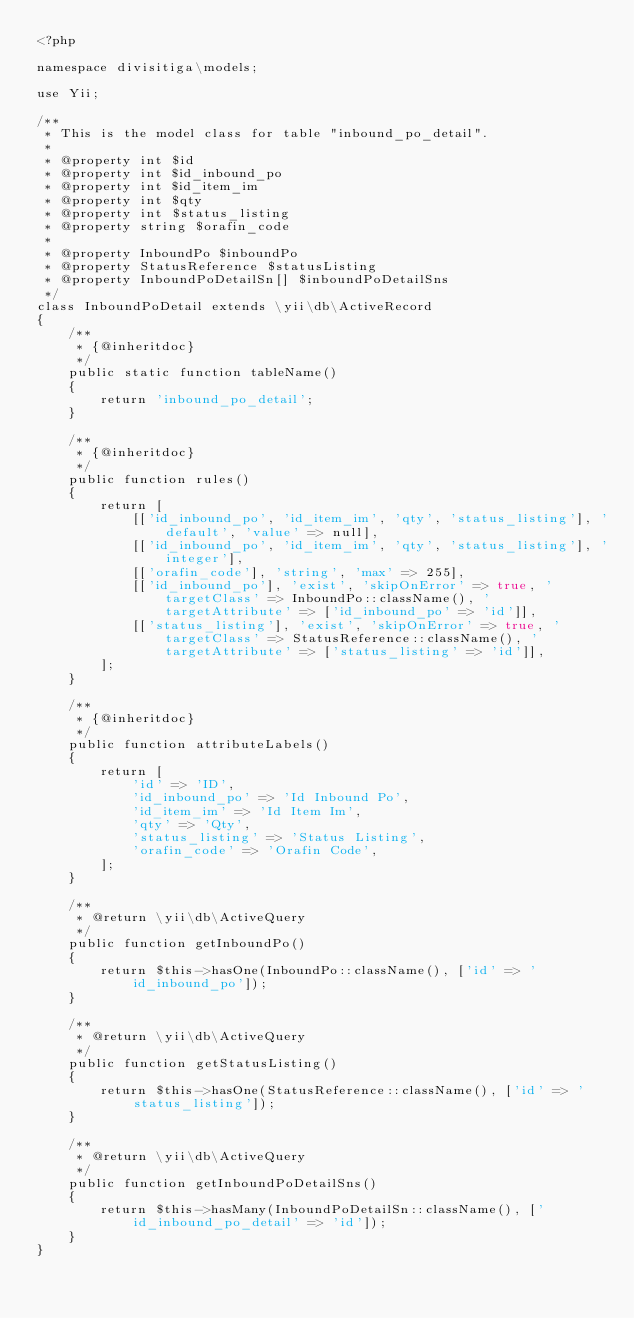<code> <loc_0><loc_0><loc_500><loc_500><_PHP_><?php

namespace divisitiga\models;

use Yii;

/**
 * This is the model class for table "inbound_po_detail".
 *
 * @property int $id
 * @property int $id_inbound_po
 * @property int $id_item_im
 * @property int $qty
 * @property int $status_listing
 * @property string $orafin_code
 *
 * @property InboundPo $inboundPo
 * @property StatusReference $statusListing
 * @property InboundPoDetailSn[] $inboundPoDetailSns
 */
class InboundPoDetail extends \yii\db\ActiveRecord
{
    /**
     * {@inheritdoc}
     */
    public static function tableName()
    {
        return 'inbound_po_detail';
    }

    /**
     * {@inheritdoc}
     */
    public function rules()
    {
        return [
            [['id_inbound_po', 'id_item_im', 'qty', 'status_listing'], 'default', 'value' => null],
            [['id_inbound_po', 'id_item_im', 'qty', 'status_listing'], 'integer'],
            [['orafin_code'], 'string', 'max' => 255],
            [['id_inbound_po'], 'exist', 'skipOnError' => true, 'targetClass' => InboundPo::className(), 'targetAttribute' => ['id_inbound_po' => 'id']],
            [['status_listing'], 'exist', 'skipOnError' => true, 'targetClass' => StatusReference::className(), 'targetAttribute' => ['status_listing' => 'id']],
        ];
    }

    /**
     * {@inheritdoc}
     */
    public function attributeLabels()
    {
        return [
            'id' => 'ID',
            'id_inbound_po' => 'Id Inbound Po',
            'id_item_im' => 'Id Item Im',
            'qty' => 'Qty',
            'status_listing' => 'Status Listing',
            'orafin_code' => 'Orafin Code',
        ];
    }

    /**
     * @return \yii\db\ActiveQuery
     */
    public function getInboundPo()
    {
        return $this->hasOne(InboundPo::className(), ['id' => 'id_inbound_po']);
    }

    /**
     * @return \yii\db\ActiveQuery
     */
    public function getStatusListing()
    {
        return $this->hasOne(StatusReference::className(), ['id' => 'status_listing']);
    }

    /**
     * @return \yii\db\ActiveQuery
     */
    public function getInboundPoDetailSns()
    {
        return $this->hasMany(InboundPoDetailSn::className(), ['id_inbound_po_detail' => 'id']);
    }
}
</code> 